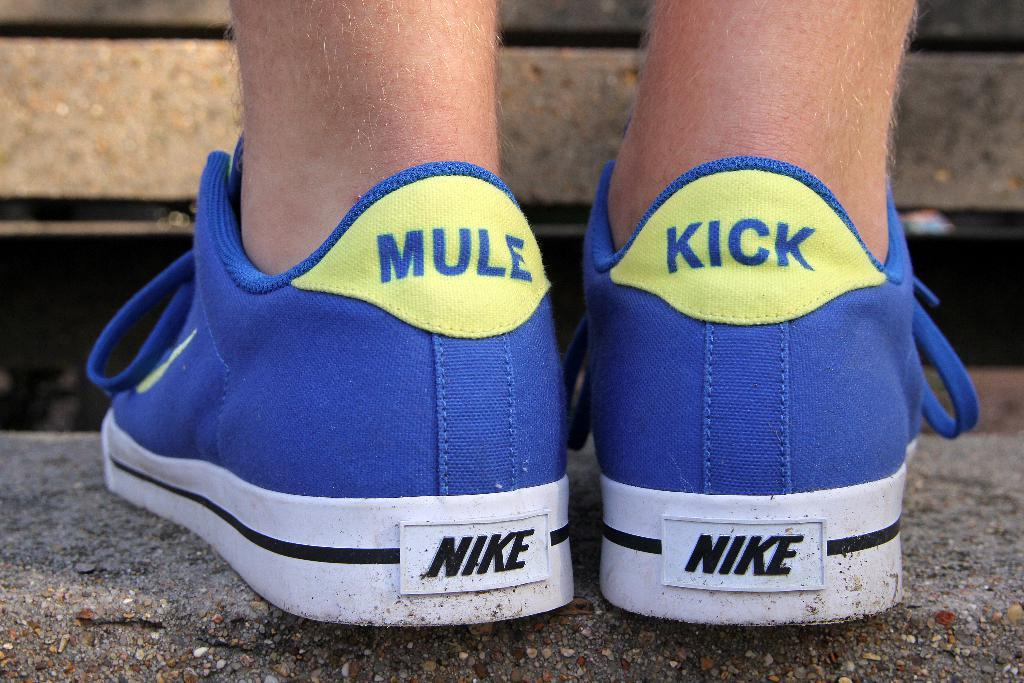<image>
Provide a brief description of the given image. a couple of shoes where one says mule on it 